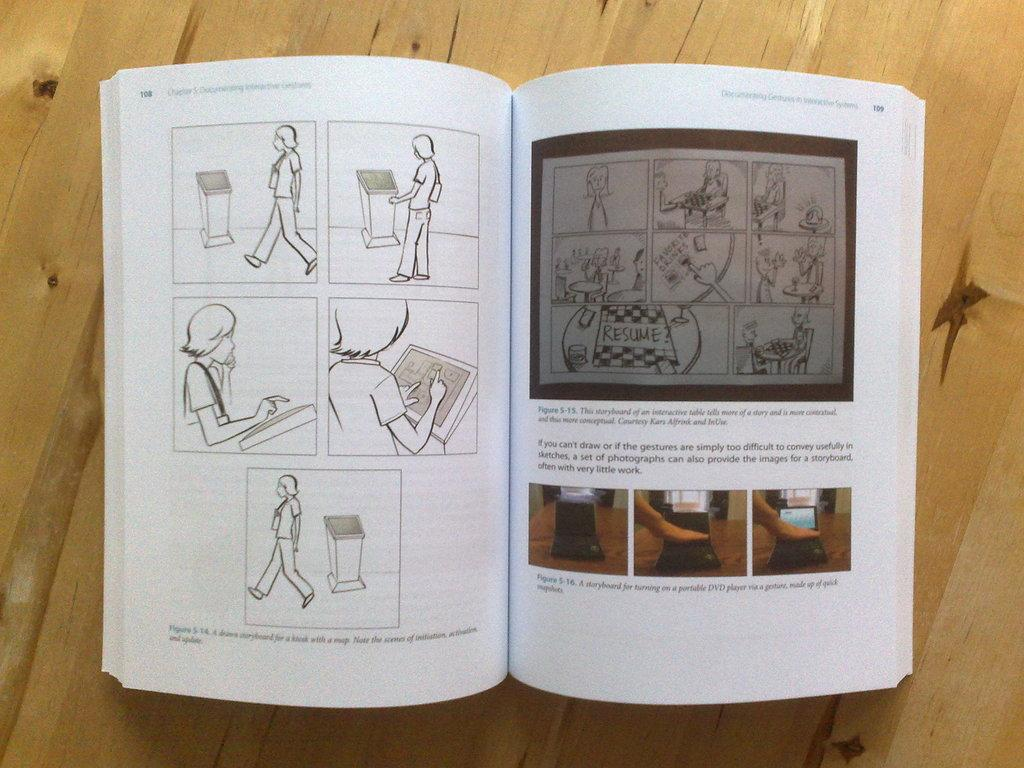<image>
Create a compact narrative representing the image presented. Pages 108 and 109 contain many illustrations and pictures. 